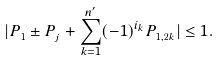Convert formula to latex. <formula><loc_0><loc_0><loc_500><loc_500>| P _ { _ { 1 } } \pm P _ { _ { j } } + \sum _ { k = 1 } ^ { n ^ { \prime } } ( - 1 ) ^ { i _ { k } } P _ { _ { 1 , 2 k } } | \leq 1 .</formula> 